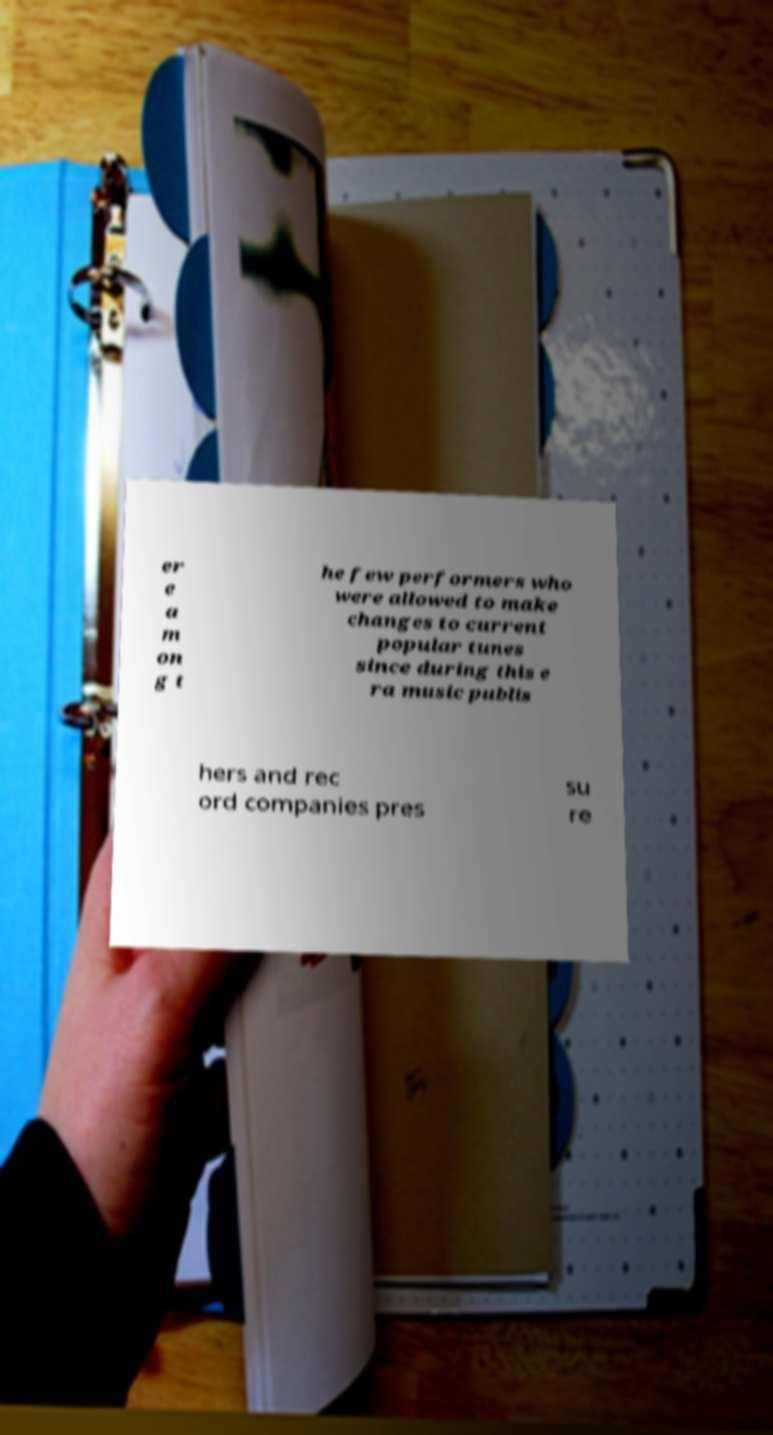I need the written content from this picture converted into text. Can you do that? er e a m on g t he few performers who were allowed to make changes to current popular tunes since during this e ra music publis hers and rec ord companies pres su re 